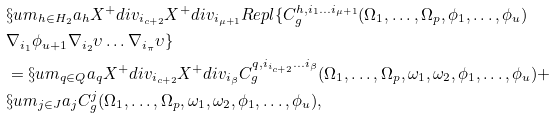Convert formula to latex. <formula><loc_0><loc_0><loc_500><loc_500>& \S u m _ { h \in H _ { 2 } } a _ { h } X ^ { + } d i v _ { i _ { c + 2 } } X ^ { + } d i v _ { i _ { \mu + 1 } } R e p l \{ C ^ { h , i _ { 1 } \dots i _ { \mu + 1 } } _ { g } ( \Omega _ { 1 } , \dots , \Omega _ { p } , \phi _ { 1 } , \dots , \phi _ { u } ) \\ & \nabla _ { i _ { 1 } } \phi _ { u + 1 } \nabla _ { i _ { 2 } } \upsilon \dots \nabla _ { i _ { \pi } } \upsilon \} \\ & = \S u m _ { q \in Q } a _ { q } X ^ { + } d i v _ { i _ { c + 2 } } X ^ { + } d i v _ { i _ { \beta } } C ^ { q , i _ { i _ { c + 2 } } \dots i _ { \beta } } _ { g } ( \Omega _ { 1 } , \dots , \Omega _ { p } , \omega _ { 1 } , \omega _ { 2 } , \phi _ { 1 } , \dots , \phi _ { u } ) + \\ & \S u m _ { j \in J } a _ { j } C ^ { j } _ { g } ( \Omega _ { 1 } , \dots , \Omega _ { p } , \omega _ { 1 } , \omega _ { 2 } , \phi _ { 1 } , \dots , \phi _ { u } ) ,</formula> 